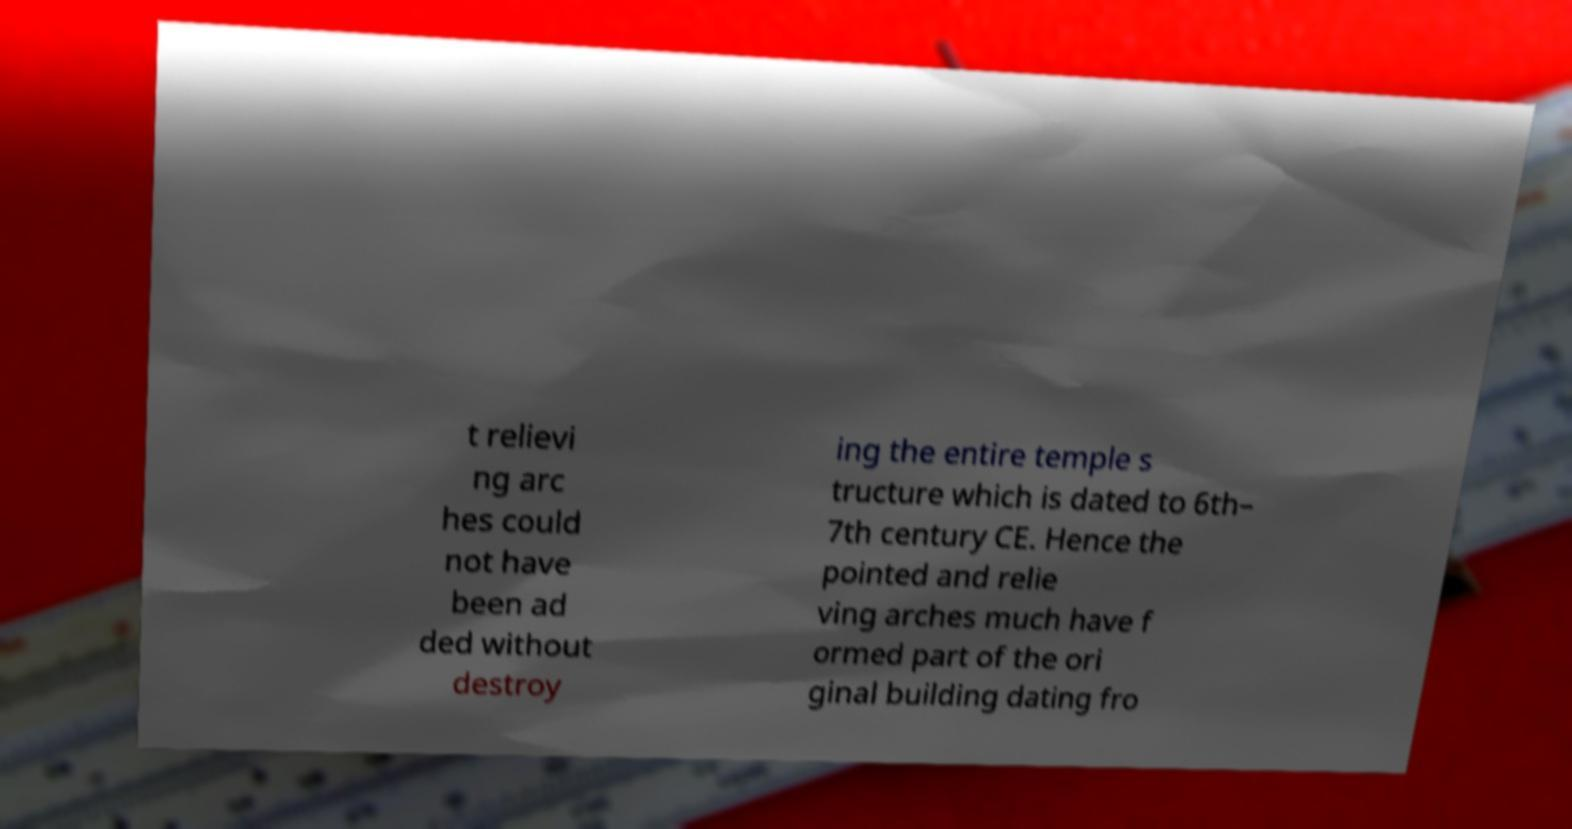For documentation purposes, I need the text within this image transcribed. Could you provide that? t relievi ng arc hes could not have been ad ded without destroy ing the entire temple s tructure which is dated to 6th– 7th century CE. Hence the pointed and relie ving arches much have f ormed part of the ori ginal building dating fro 